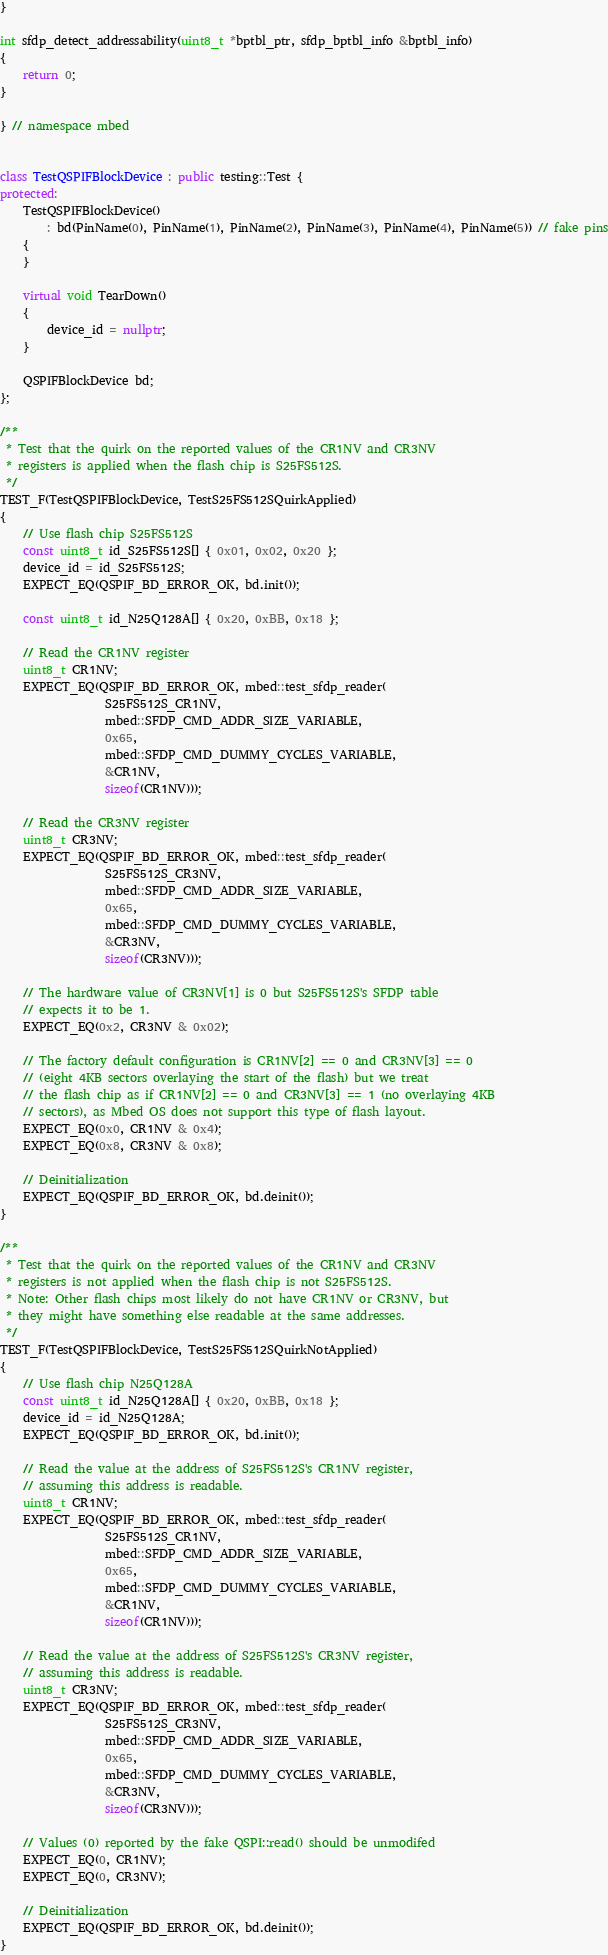<code> <loc_0><loc_0><loc_500><loc_500><_C++_>}

int sfdp_detect_addressability(uint8_t *bptbl_ptr, sfdp_bptbl_info &bptbl_info)
{
    return 0;
}

} // namespace mbed


class TestQSPIFBlockDevice : public testing::Test {
protected:
    TestQSPIFBlockDevice()
        : bd(PinName(0), PinName(1), PinName(2), PinName(3), PinName(4), PinName(5)) // fake pins
    {
    }

    virtual void TearDown()
    {
        device_id = nullptr;
    }

    QSPIFBlockDevice bd;
};

/**
 * Test that the quirk on the reported values of the CR1NV and CR3NV
 * registers is applied when the flash chip is S25FS512S.
 */
TEST_F(TestQSPIFBlockDevice, TestS25FS512SQuirkApplied)
{
    // Use flash chip S25FS512S
    const uint8_t id_S25FS512S[] { 0x01, 0x02, 0x20 };
    device_id = id_S25FS512S;
    EXPECT_EQ(QSPIF_BD_ERROR_OK, bd.init());

    const uint8_t id_N25Q128A[] { 0x20, 0xBB, 0x18 };

    // Read the CR1NV register
    uint8_t CR1NV;
    EXPECT_EQ(QSPIF_BD_ERROR_OK, mbed::test_sfdp_reader(
                  S25FS512S_CR1NV,
                  mbed::SFDP_CMD_ADDR_SIZE_VARIABLE,
                  0x65,
                  mbed::SFDP_CMD_DUMMY_CYCLES_VARIABLE,
                  &CR1NV,
                  sizeof(CR1NV)));

    // Read the CR3NV register
    uint8_t CR3NV;
    EXPECT_EQ(QSPIF_BD_ERROR_OK, mbed::test_sfdp_reader(
                  S25FS512S_CR3NV,
                  mbed::SFDP_CMD_ADDR_SIZE_VARIABLE,
                  0x65,
                  mbed::SFDP_CMD_DUMMY_CYCLES_VARIABLE,
                  &CR3NV,
                  sizeof(CR3NV)));

    // The hardware value of CR3NV[1] is 0 but S25FS512S's SFDP table
    // expects it to be 1.
    EXPECT_EQ(0x2, CR3NV & 0x02);

    // The factory default configuration is CR1NV[2] == 0 and CR3NV[3] == 0
    // (eight 4KB sectors overlaying the start of the flash) but we treat
    // the flash chip as if CR1NV[2] == 0 and CR3NV[3] == 1 (no overlaying 4KB
    // sectors), as Mbed OS does not support this type of flash layout.
    EXPECT_EQ(0x0, CR1NV & 0x4);
    EXPECT_EQ(0x8, CR3NV & 0x8);

    // Deinitialization
    EXPECT_EQ(QSPIF_BD_ERROR_OK, bd.deinit());
}

/**
 * Test that the quirk on the reported values of the CR1NV and CR3NV
 * registers is not applied when the flash chip is not S25FS512S.
 * Note: Other flash chips most likely do not have CR1NV or CR3NV, but
 * they might have something else readable at the same addresses.
 */
TEST_F(TestQSPIFBlockDevice, TestS25FS512SQuirkNotApplied)
{
    // Use flash chip N25Q128A
    const uint8_t id_N25Q128A[] { 0x20, 0xBB, 0x18 };
    device_id = id_N25Q128A;
    EXPECT_EQ(QSPIF_BD_ERROR_OK, bd.init());

    // Read the value at the address of S25FS512S's CR1NV register,
    // assuming this address is readable.
    uint8_t CR1NV;
    EXPECT_EQ(QSPIF_BD_ERROR_OK, mbed::test_sfdp_reader(
                  S25FS512S_CR1NV,
                  mbed::SFDP_CMD_ADDR_SIZE_VARIABLE,
                  0x65,
                  mbed::SFDP_CMD_DUMMY_CYCLES_VARIABLE,
                  &CR1NV,
                  sizeof(CR1NV)));

    // Read the value at the address of S25FS512S's CR3NV register,
    // assuming this address is readable.
    uint8_t CR3NV;
    EXPECT_EQ(QSPIF_BD_ERROR_OK, mbed::test_sfdp_reader(
                  S25FS512S_CR3NV,
                  mbed::SFDP_CMD_ADDR_SIZE_VARIABLE,
                  0x65,
                  mbed::SFDP_CMD_DUMMY_CYCLES_VARIABLE,
                  &CR3NV,
                  sizeof(CR3NV)));

    // Values (0) reported by the fake QSPI::read() should be unmodifed
    EXPECT_EQ(0, CR1NV);
    EXPECT_EQ(0, CR3NV);

    // Deinitialization
    EXPECT_EQ(QSPIF_BD_ERROR_OK, bd.deinit());
}
</code> 